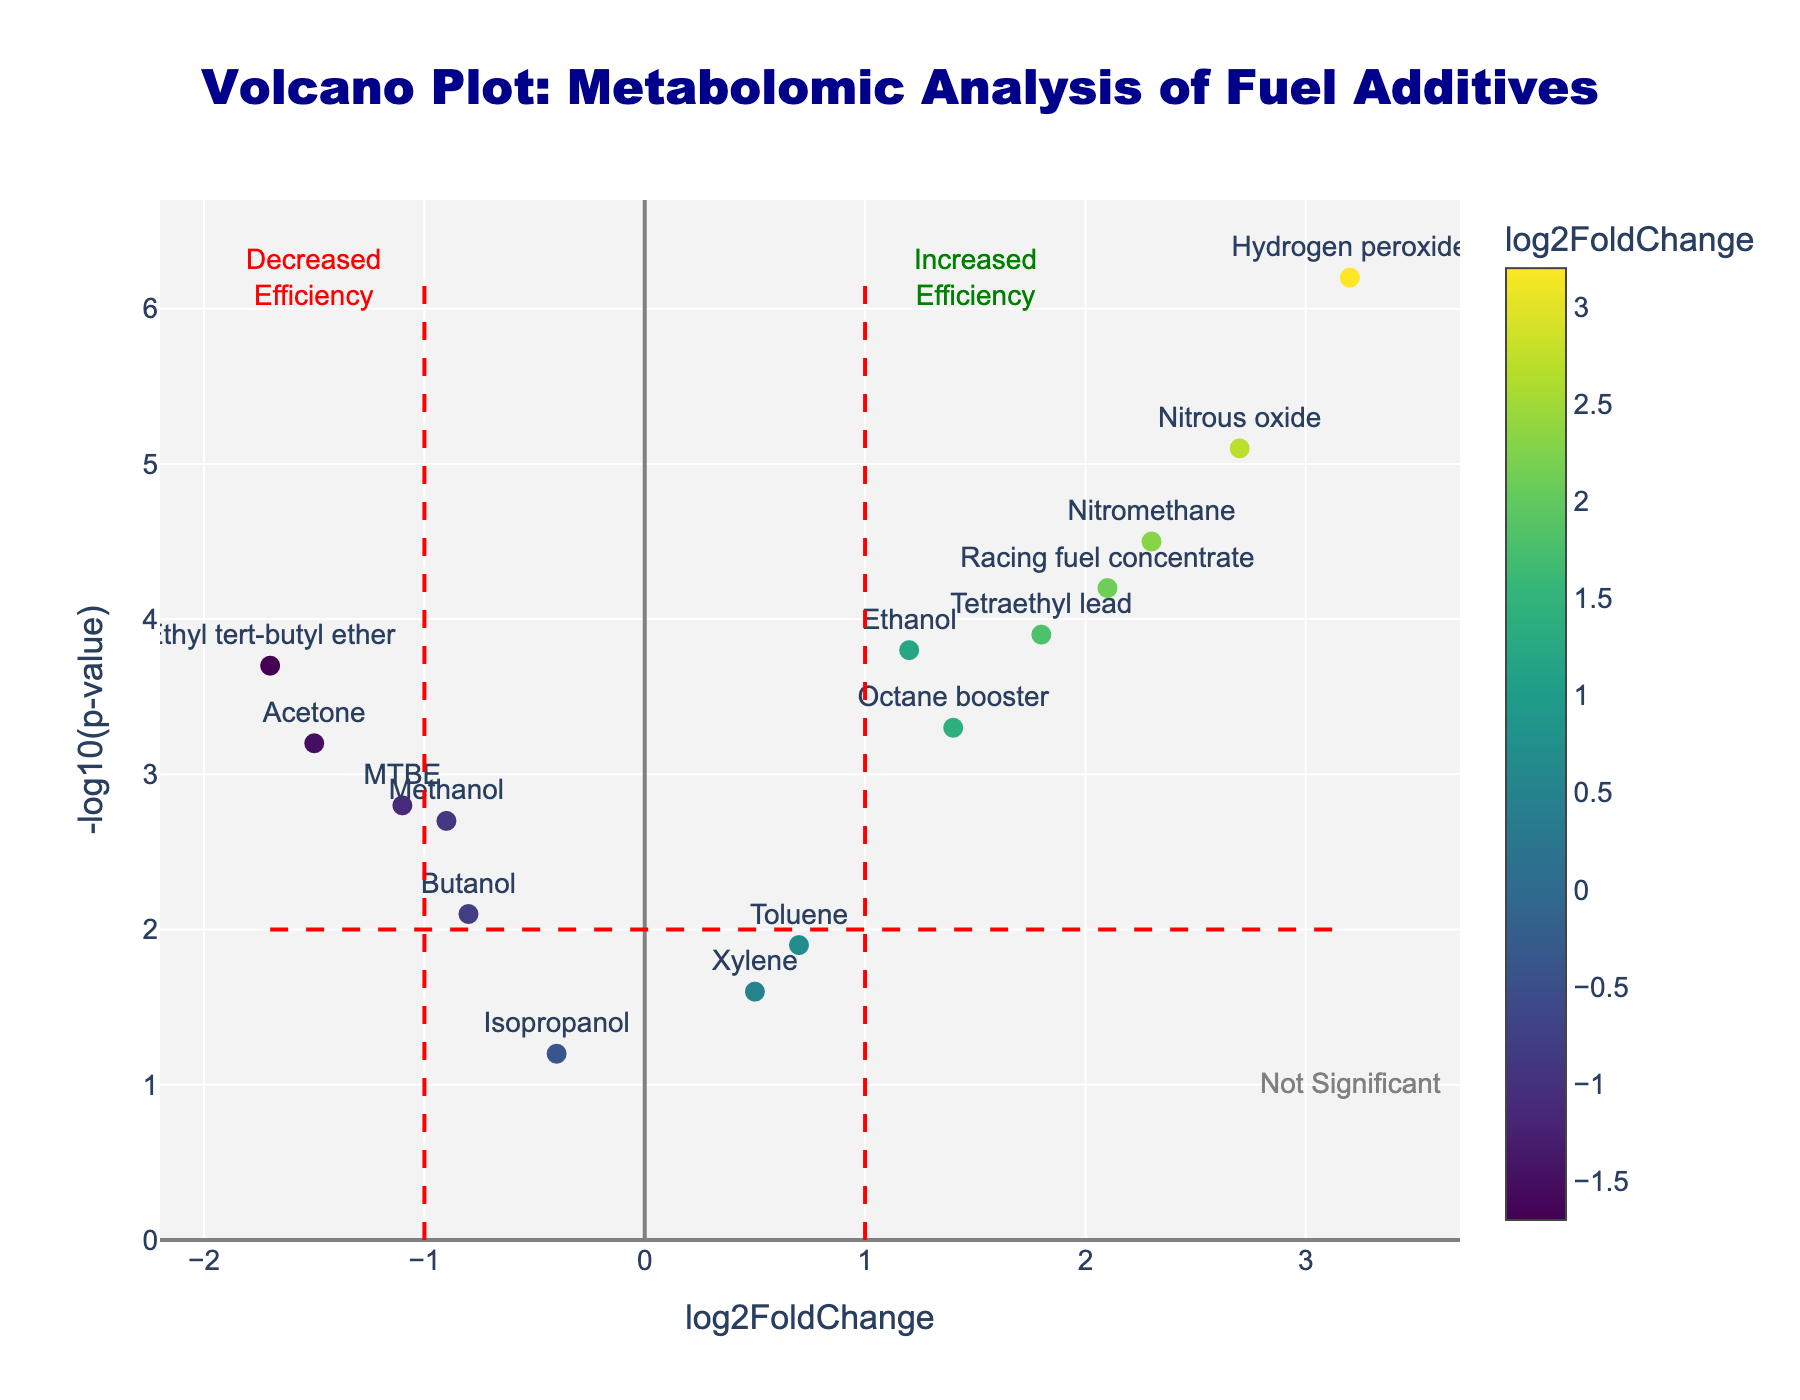What is the title of the plot? The title of the plot is located at the top center and reads "Volcano Plot: Metabolomic Analysis of Fuel Additives."
Answer: Volcano Plot: Metabolomic Analysis of Fuel Additives How many fuel additives have increased efficiency? Fuel additives are represented by points on the right side of the vertical line at log2FoldChange = 1. Count these points to find the number of additives with increased efficiency.
Answer: 8 Which additive shows the highest increase in efficiency? Check the additive with the highest log2FoldChange value on the right side of the vertical lines.
Answer: Hydrogen peroxide Which additive indicates the most significant effect? The most significant effect is shown by the highest -log10(p-value) on the y-axis.
Answer: Hydrogen peroxide Which additive shows a decrease in efficiency but is still statistically significant? Look for an additive with a negative log2FoldChange and a -log10(p-value) above 2, indicating statistical significance.
Answer: Acetone What is the log2FoldChange value for Tetraethyl lead? Find the label "Tetraethyl lead" in the plot and read its corresponding log2FoldChange value.
Answer: 1.8 How many additives show insignificant effects based on the plot? Insignificant effects lie below the horizontal line at -log10(p-value) = 2. Count the points below this line.
Answer: 5 Which additives are closest to the threshold of log2FoldChange = ±1? Identify the points closest to the dashed vertical lines at ±1.
Answer: Methanol and Xylene What is the negLogPvalue of Racing fuel concentrate? Find the label "Racing fuel concentrate" in the plot and read its corresponding -log10(p-value) value.
Answer: 4.2 Compare the efficiency changes for Nitromethane and Ethanol. Which is higher? Compare the log2FoldChange values for Nitromethane and Ethanol, and determine which is higher.
Answer: Nitromethane 